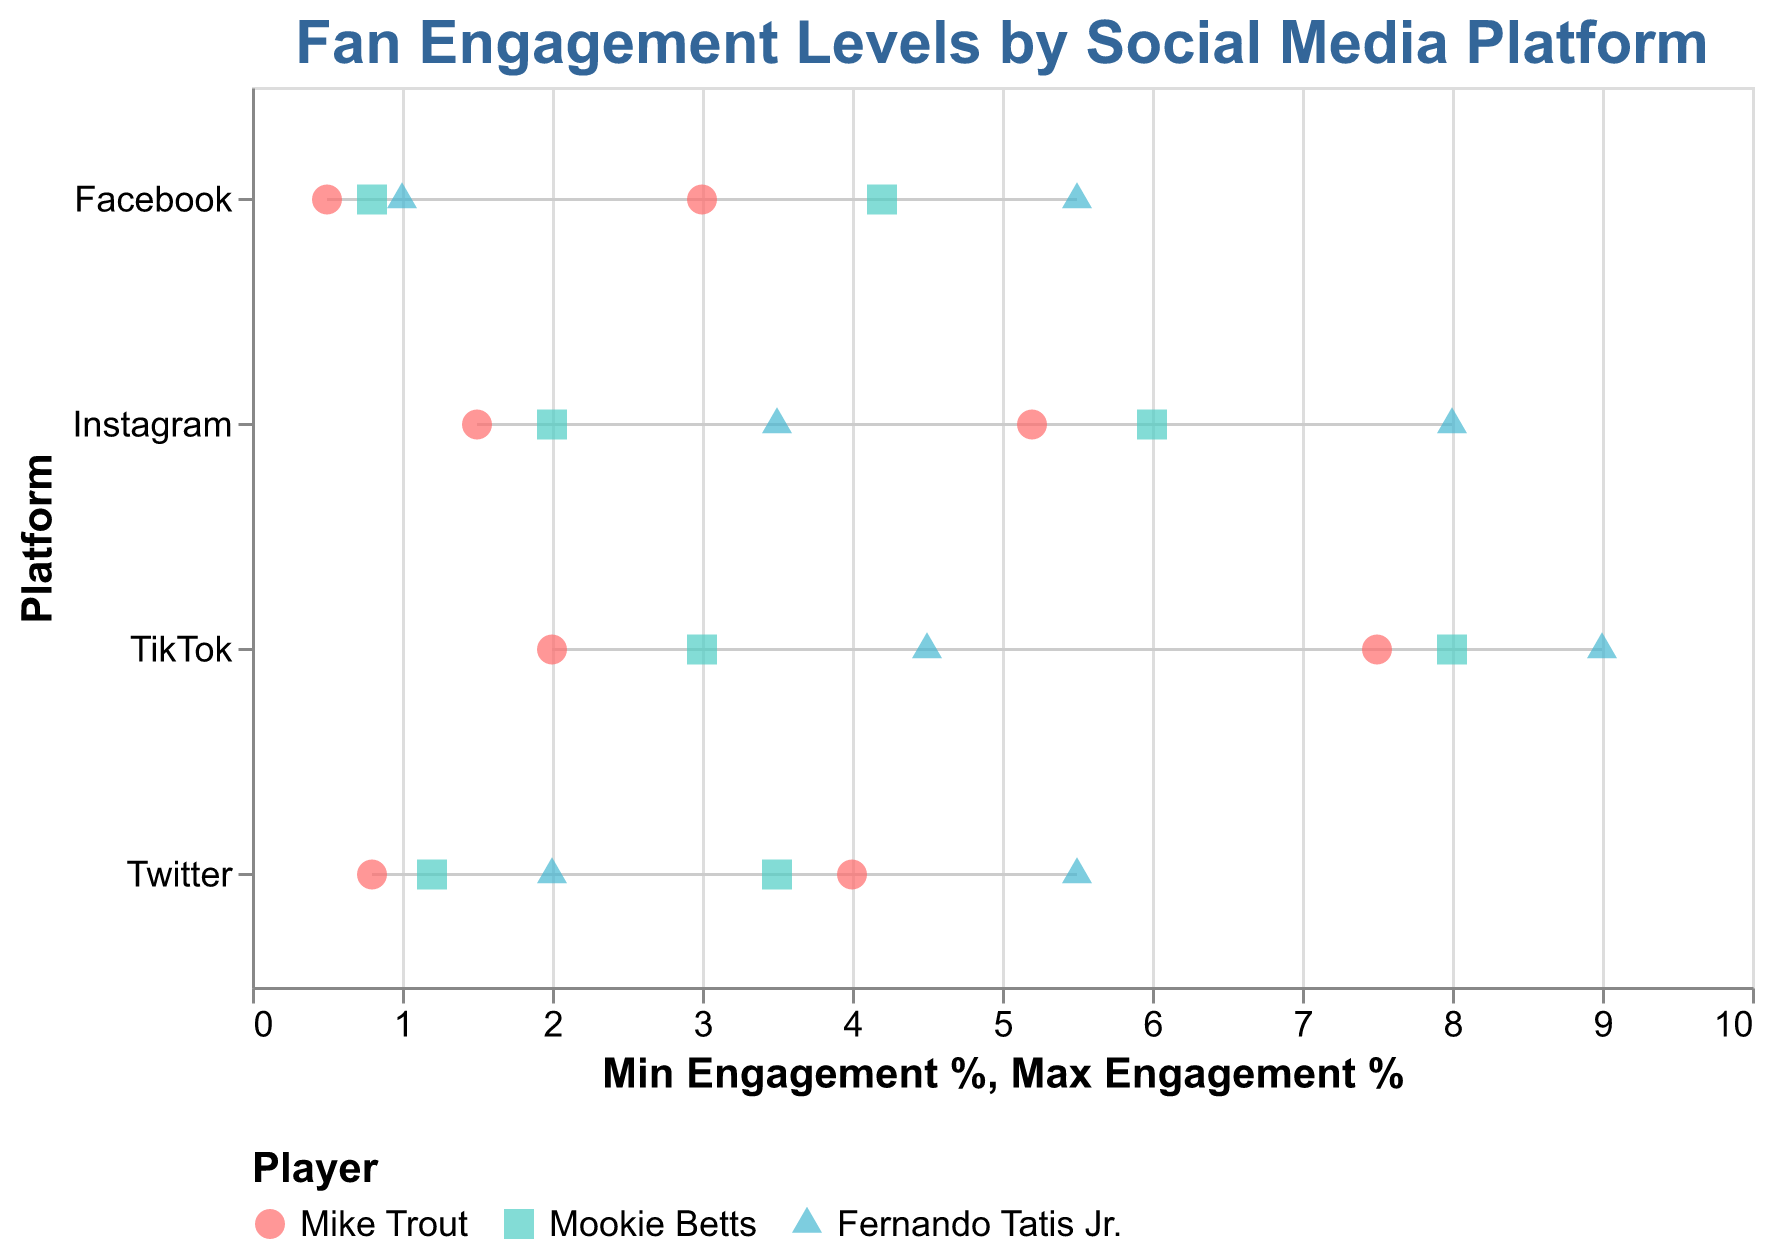What is the title of the plot? The title is at the top of the plot, written in bold font and blue color.
Answer: Fan Engagement Levels by Social Media Platform Which social media platform has the highest maximum engagement for Fernando Tatis Jr.? By looking at the plotted points for Fernando Tatis Jr., we see that TikTok has the highest maximum engagement of 9.0%.
Answer: TikTok Between Instagram and Twitter, which platform has a higher average engagement for Mike Trout? For Instagram, Mike Trout's engagement ranges from 1.5% to 5.2%. The average is (1.5 + 5.2)/2 = 3.35%. For Twitter, the engagement ranges from 0.8% to 4.0%, and the average is (0.8 + 4.0)/2 = 2.4%. Therefore, Instagram has the higher average engagement.
Answer: Instagram Which player has the narrowest engagement range on Facebook? The engagement range can be found by subtracting the min engagement from the max engagement. For Mike Trout, it is 3.0 - 0.5 = 2.5%; for Mookie Betts, it is 4.2 - 0.8 = 3.4%; for Fernando Tatis Jr., it is 5.5 - 1.0 = 4.5%. Mike Trout has the narrowest range.
Answer: Mike Trout Which social media platform has the overall highest minimum engagement level? By looking at the minimum engagement levels for all platforms, the highest minimum engagement is found on TikTok with Fernando Tatis Jr. at 4.5%.
Answer: TikTok How do the minimum engagement levels on Instagram for the three players compare to each other? On Instagram, Mike Trout has a minimum engagement of 1.5%, Mookie Betts has 2.0%, and Fernando Tatis Jr. has 3.5%. Comparing these, Mike Trout < Mookie Betts < Fernando Tatis Jr.
Answer: Mike Trout < Mookie Betts < Fernando Tatis Jr What is the overall visual color representation for Mookie Betts in the plot? The legend at the bottom indicates that Mookie Betts is represented by the color teal.
Answer: Teal Between Twitter and Facebook, which platform has a higher maximum engagement for Mookie Betts? For Twitter, Mookie Betts's maximum engagement is 3.5%, and for Facebook, it is 4.2%. Facebook has a higher maximum engagement.
Answer: Facebook Which player has the widest engagement range on TikTok? The engagement range is found by subtracting the min from the max. For Mike Trout, it’s 7.5 - 2.0 = 5.5%; for Mookie Betts, it’s 8.0 - 3.0 = 5.0%; for Fernando Tatis Jr., it’s 9.0 - 4.5 = 4.5%. Mike Trout has the widest range.
Answer: Mike Trout 